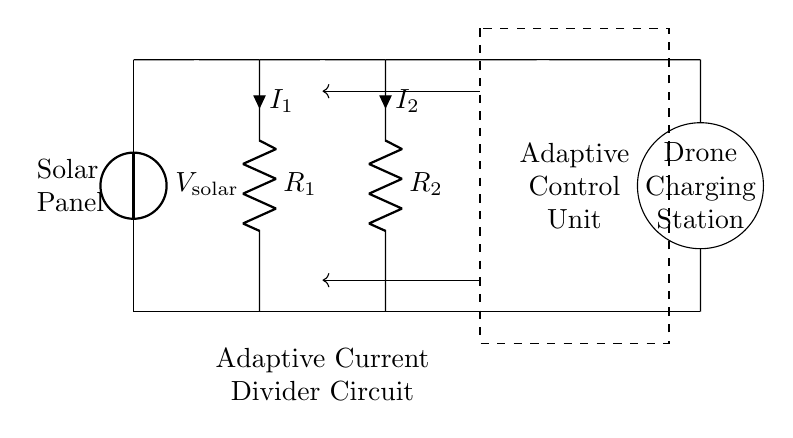what components are present in the circuit diagram? The circuit includes a solar panel, two resistors labeled R1 and R2, an adaptive control unit, and a drone charging station. These components are visually identifiable based on their symbols and labels in the diagram.
Answer: solar panel, R1, R2, adaptive control unit, drone charging station what is the purpose of the adaptive control unit in this circuit? The adaptive control unit adjusts the current flowing through the resistors based on the solar energy input to optimize the efficiency of the solar panels and subsequently charge the drone effectively. This is inferred from its context within the circuit diagram, where it influences the current directed to the charging station.
Answer: to optimize solar panel efficiency how does the current dividers' configuration affect the current distribution? The configuration of R1 and R2, in parallel, determines how the total current from the solar panel divides between them. The current division formula shows that the current inversely relates to the resistance values; thus, lower resistance gets more current. This is based on the fundamental principles of current dividers.
Answer: R1 and R2 affect current distribution what represents the charging station in the circuit? The drone charging station is represented by a circle labeled accordingly, indicating it serves as a load where the collected energy from the solar panels through the adaptive control circuit is utilized for charging.
Answer: circle labeled "Drone Charging Station." how would we calculate the total current flowing from the solar panel? The total current flowing from the solar panel can be calculated using Ohm's law and the combined resistance of R1 and R2 in parallel. The formula for total current I_total from the voltage source V_solar is I_total = V_solar / (R_eq), where R_eq = (R1 * R2) / (R1 + R2). This is inferred from the common principles of electrical circuits, specifically current dividers.
Answer: I_total = V_solar / R_eq what is the significance of having R1 and R2 as resistors in this circuit? R1 and R2 function as current limiters in the adaptive current divider configuration. The values of these resistors determine how the total current from the solar panel is split, which is essential for balancing the load on the charging station and optimizing the overall efficiency of power distribution. This significance arises from their positions in the circuit and their roles in current division.
Answer: to split the current for efficient charging 